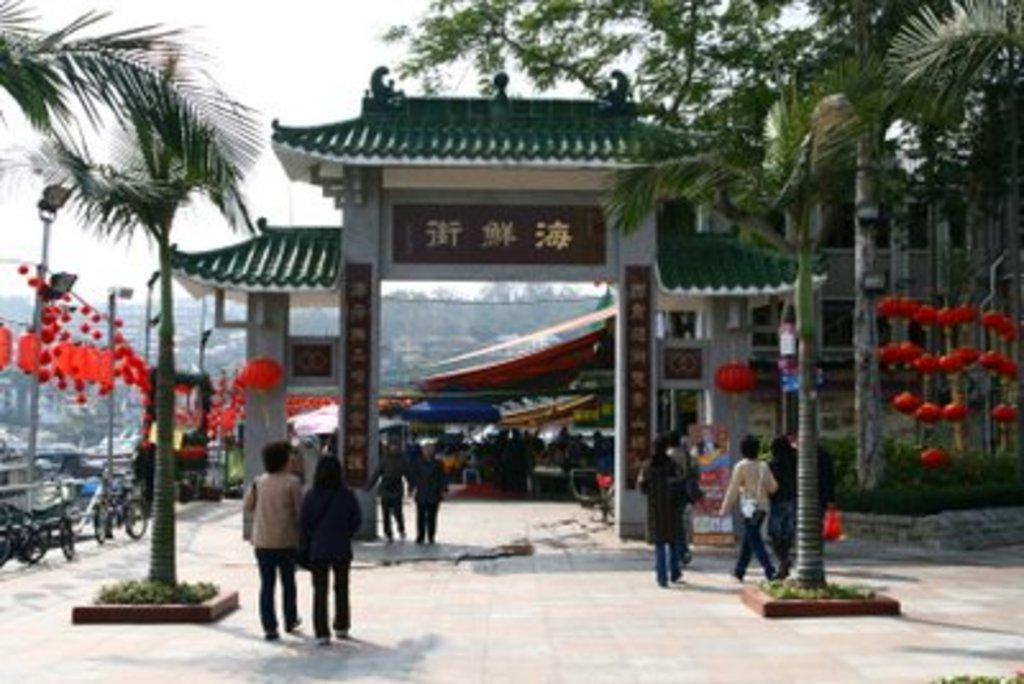Can you describe this image briefly? In this picture we can see group of people,vehicles and here we can see trees,sky. 